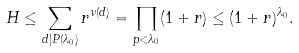Convert formula to latex. <formula><loc_0><loc_0><loc_500><loc_500>H \leq \sum _ { d | P ( \lambda _ { 0 } ) } r ^ { \nu ( d ) } = \prod _ { p < \lambda _ { 0 } } ( 1 + r ) \leq ( 1 + r ) ^ { \lambda _ { 0 } } .</formula> 